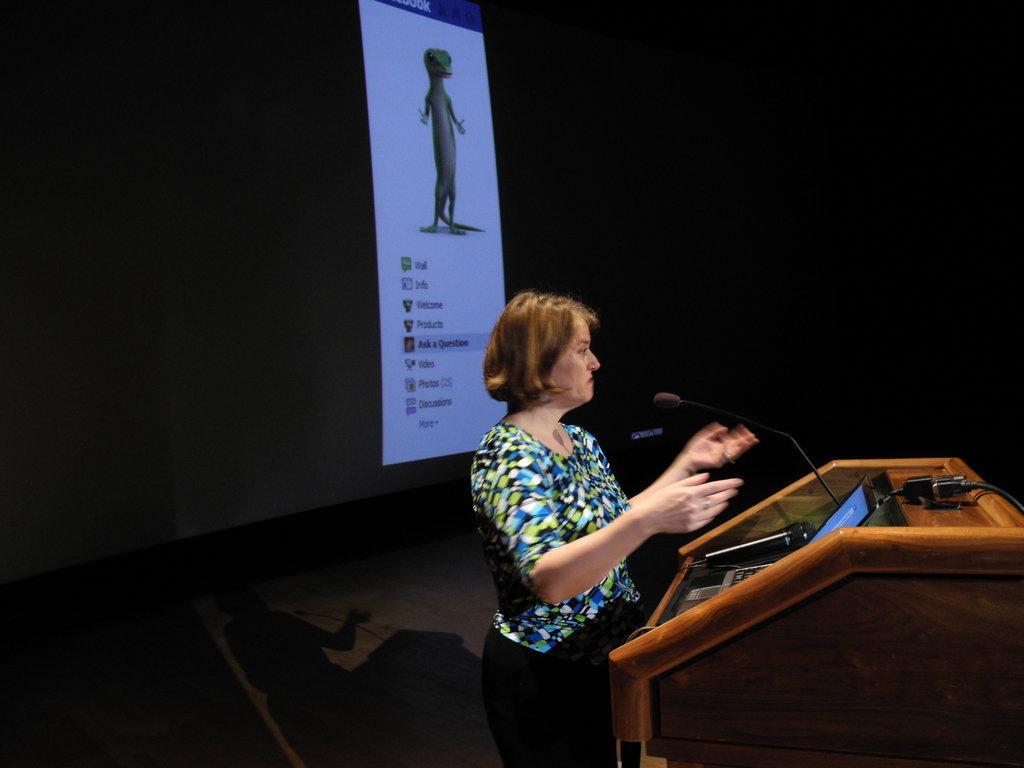How would you summarize this image in a sentence or two? There is a woman standing,in front of this woman we can see microphone,laptop and cable on the podium. In the background it is dark and we can see screen. 